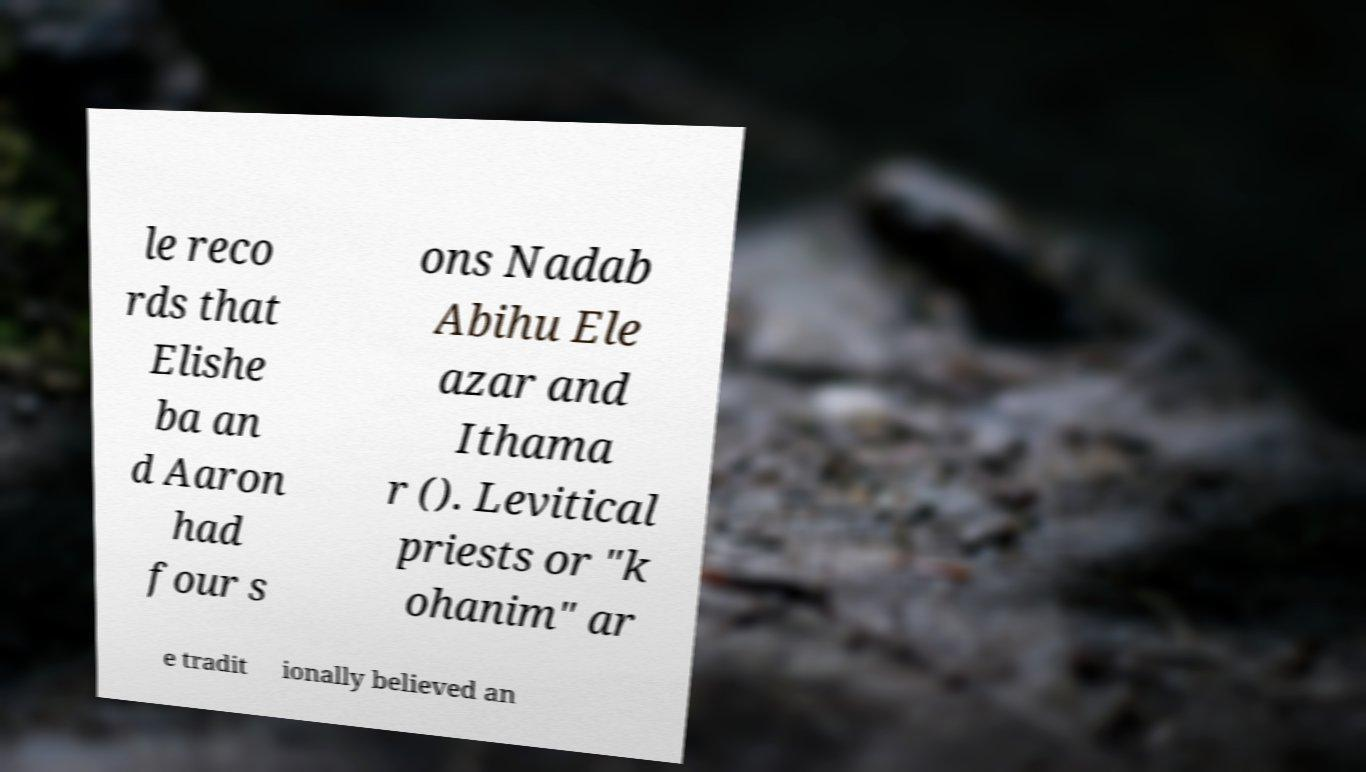Can you accurately transcribe the text from the provided image for me? le reco rds that Elishe ba an d Aaron had four s ons Nadab Abihu Ele azar and Ithama r (). Levitical priests or "k ohanim" ar e tradit ionally believed an 